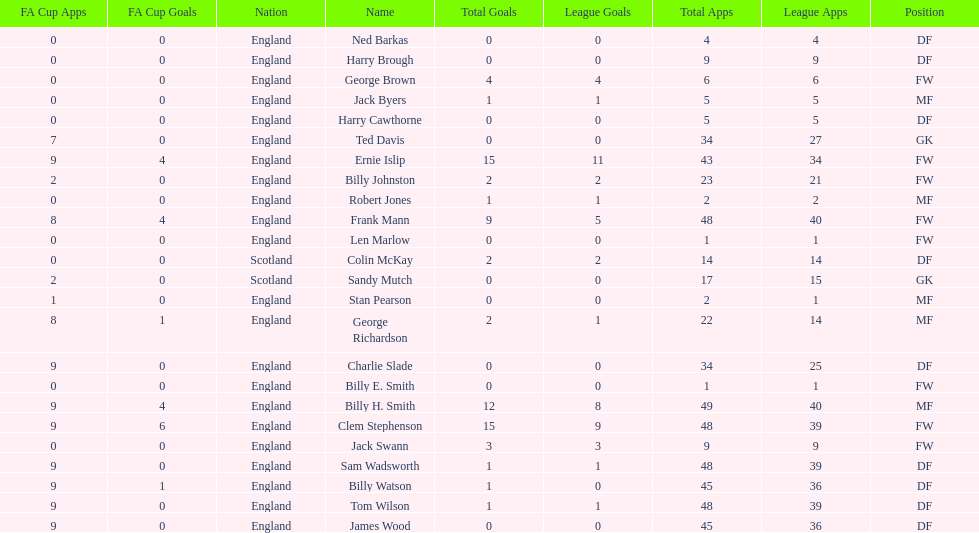What is the first name listed? Ned Barkas. 